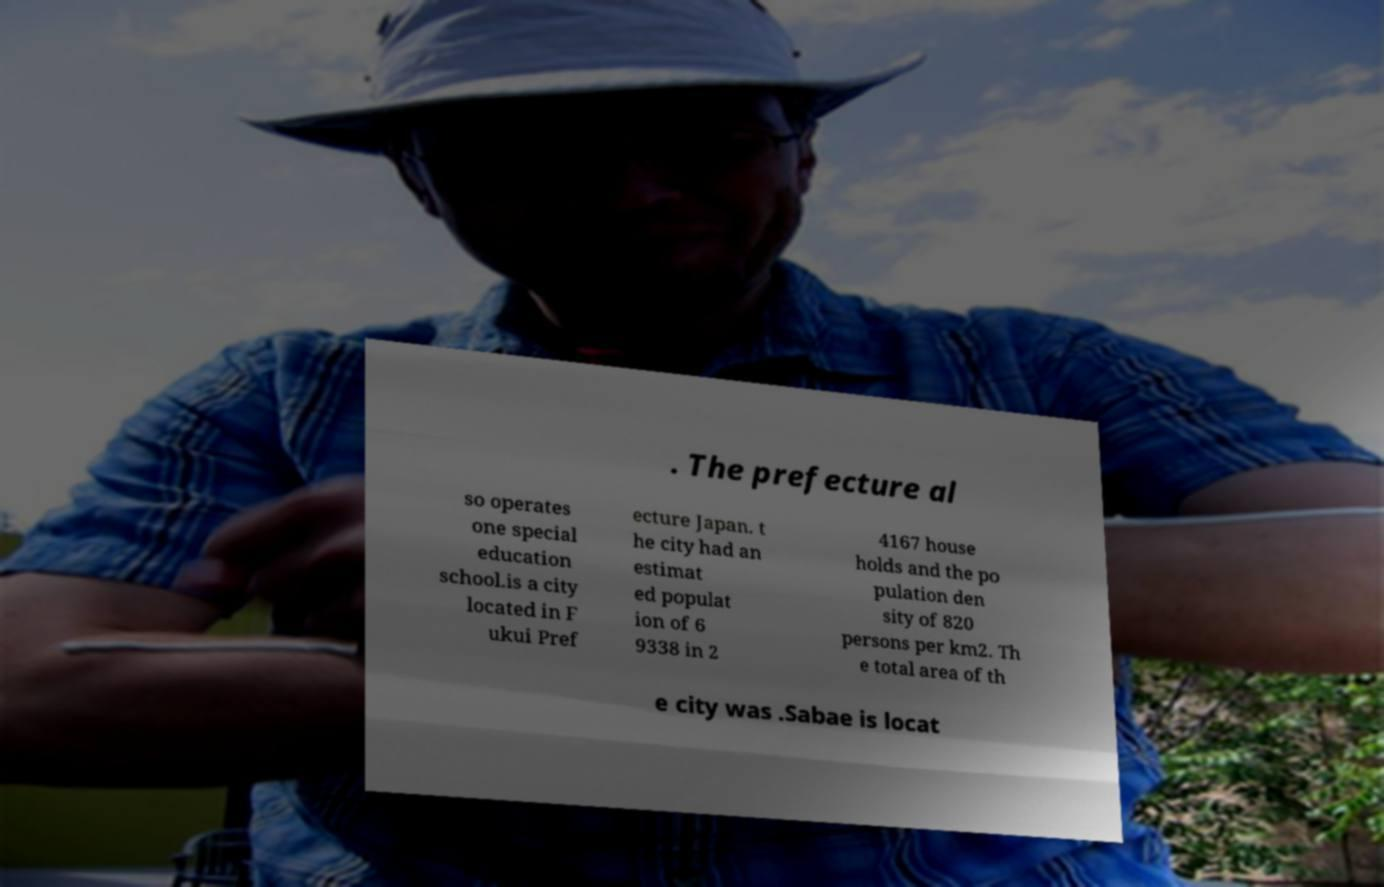What messages or text are displayed in this image? I need them in a readable, typed format. . The prefecture al so operates one special education school.is a city located in F ukui Pref ecture Japan. t he city had an estimat ed populat ion of 6 9338 in 2 4167 house holds and the po pulation den sity of 820 persons per km2. Th e total area of th e city was .Sabae is locat 